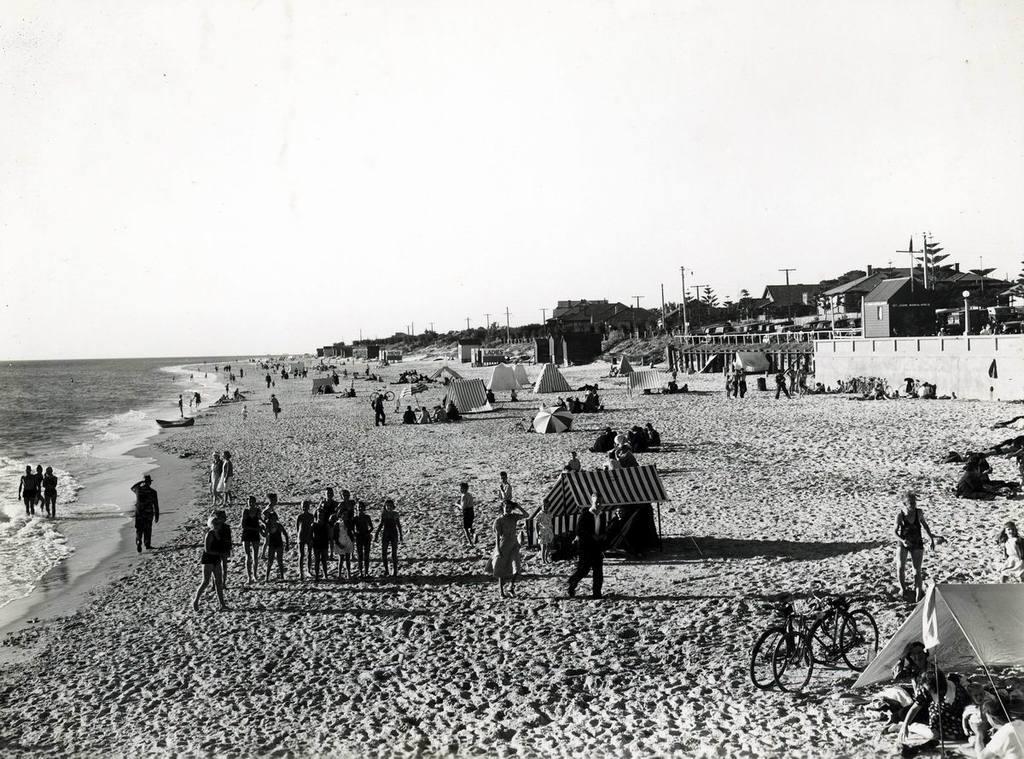Describe this image in one or two sentences. This is a black and white image. Here I can see many people in the beach. On the left side, I can see the water. There are many tents and vehicles. In the background there are buildings and poles. At the top of the image I can see the sky. 